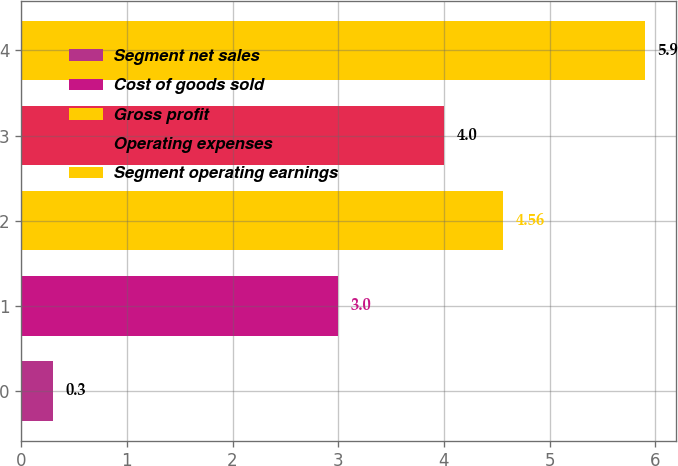Convert chart. <chart><loc_0><loc_0><loc_500><loc_500><bar_chart><fcel>Segment net sales<fcel>Cost of goods sold<fcel>Gross profit<fcel>Operating expenses<fcel>Segment operating earnings<nl><fcel>0.3<fcel>3<fcel>4.56<fcel>4<fcel>5.9<nl></chart> 